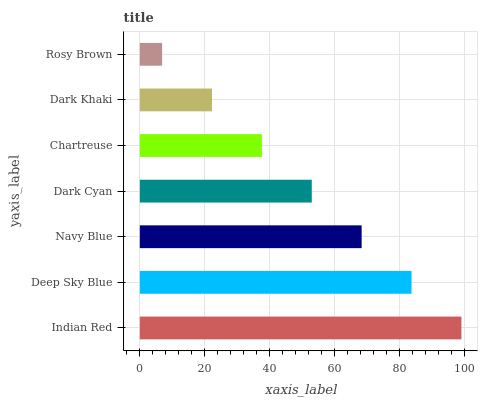Is Rosy Brown the minimum?
Answer yes or no. Yes. Is Indian Red the maximum?
Answer yes or no. Yes. Is Deep Sky Blue the minimum?
Answer yes or no. No. Is Deep Sky Blue the maximum?
Answer yes or no. No. Is Indian Red greater than Deep Sky Blue?
Answer yes or no. Yes. Is Deep Sky Blue less than Indian Red?
Answer yes or no. Yes. Is Deep Sky Blue greater than Indian Red?
Answer yes or no. No. Is Indian Red less than Deep Sky Blue?
Answer yes or no. No. Is Dark Cyan the high median?
Answer yes or no. Yes. Is Dark Cyan the low median?
Answer yes or no. Yes. Is Deep Sky Blue the high median?
Answer yes or no. No. Is Dark Khaki the low median?
Answer yes or no. No. 